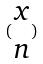Convert formula to latex. <formula><loc_0><loc_0><loc_500><loc_500>( \begin{matrix} x \\ n \end{matrix} )</formula> 